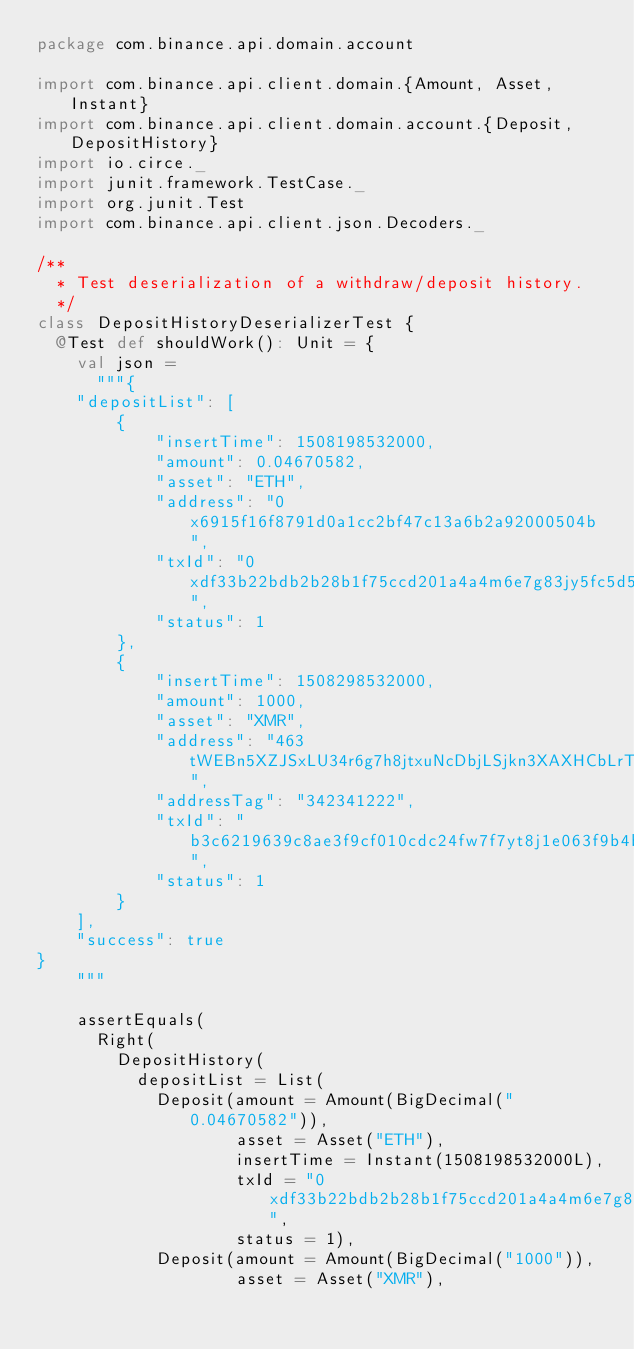<code> <loc_0><loc_0><loc_500><loc_500><_Scala_>package com.binance.api.domain.account

import com.binance.api.client.domain.{Amount, Asset, Instant}
import com.binance.api.client.domain.account.{Deposit, DepositHistory}
import io.circe._
import junit.framework.TestCase._
import org.junit.Test
import com.binance.api.client.json.Decoders._

/**
  * Test deserialization of a withdraw/deposit history.
  */
class DepositHistoryDeserializerTest {
  @Test def shouldWork(): Unit = {
    val json =
      """{
    "depositList": [
        {
            "insertTime": 1508198532000,
            "amount": 0.04670582,
            "asset": "ETH",
            "address": "0x6915f16f8791d0a1cc2bf47c13a6b2a92000504b",
            "txId": "0xdf33b22bdb2b28b1f75ccd201a4a4m6e7g83jy5fc5d5a9d1340961598cfcb0a1",
            "status": 1
        },
        {
            "insertTime": 1508298532000,
            "amount": 1000,
            "asset": "XMR",
            "address": "463tWEBn5XZJSxLU34r6g7h8jtxuNcDbjLSjkn3XAXHCbLrTTErJrBWYgHJQyrCwkNgYvyV3z8zctJLPCZy24jvb3NiTcTJ",
            "addressTag": "342341222",
            "txId": "b3c6219639c8ae3f9cf010cdc24fw7f7yt8j1e063f9b4bd1a05cb44c4b6e2509",
            "status": 1
        }
    ],
    "success": true
}
		"""

    assertEquals(
      Right(
        DepositHistory(
          depositList = List(
            Deposit(amount = Amount(BigDecimal("0.04670582")),
                    asset = Asset("ETH"),
                    insertTime = Instant(1508198532000L),
                    txId = "0xdf33b22bdb2b28b1f75ccd201a4a4m6e7g83jy5fc5d5a9d1340961598cfcb0a1",
                    status = 1),
            Deposit(amount = Amount(BigDecimal("1000")),
                    asset = Asset("XMR"),</code> 